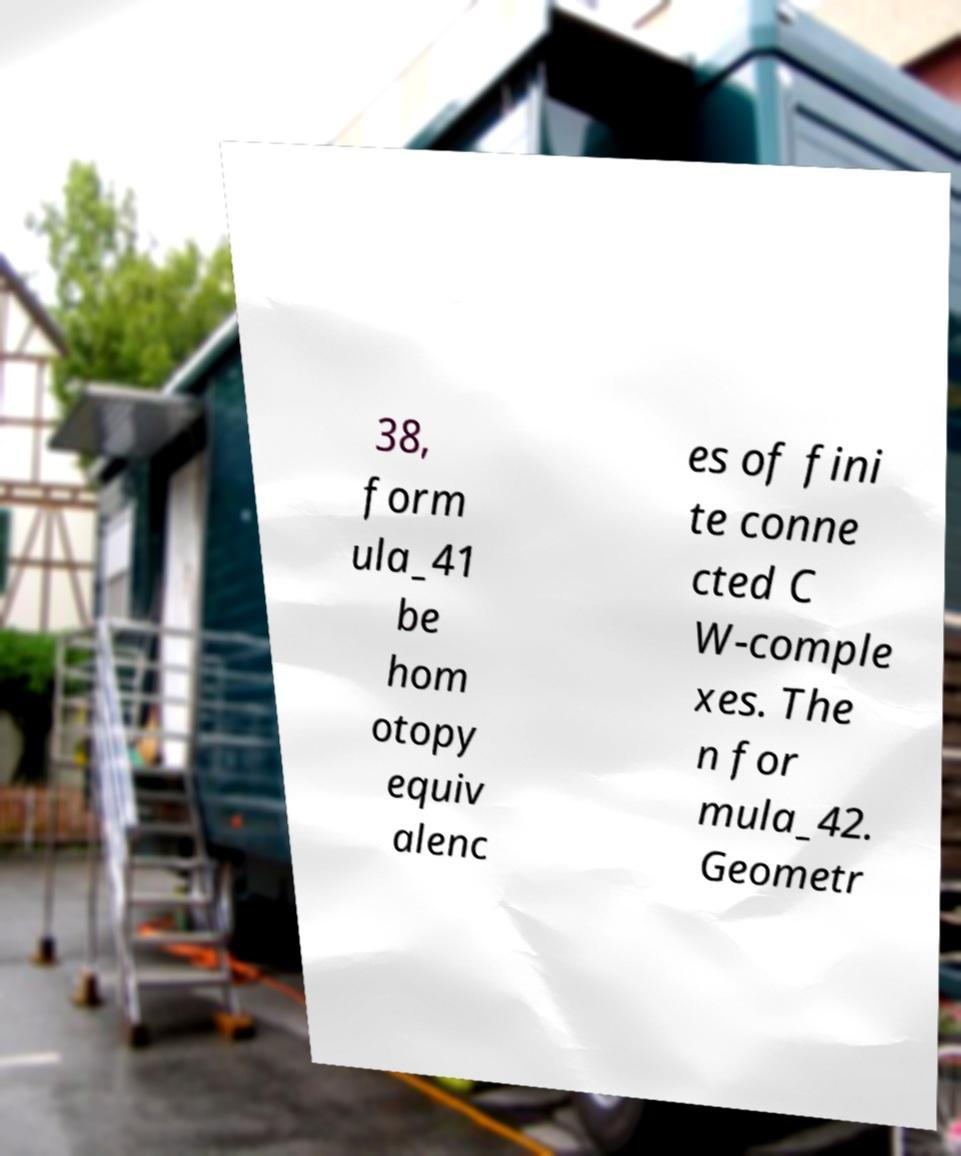There's text embedded in this image that I need extracted. Can you transcribe it verbatim? 38, form ula_41 be hom otopy equiv alenc es of fini te conne cted C W-comple xes. The n for mula_42. Geometr 